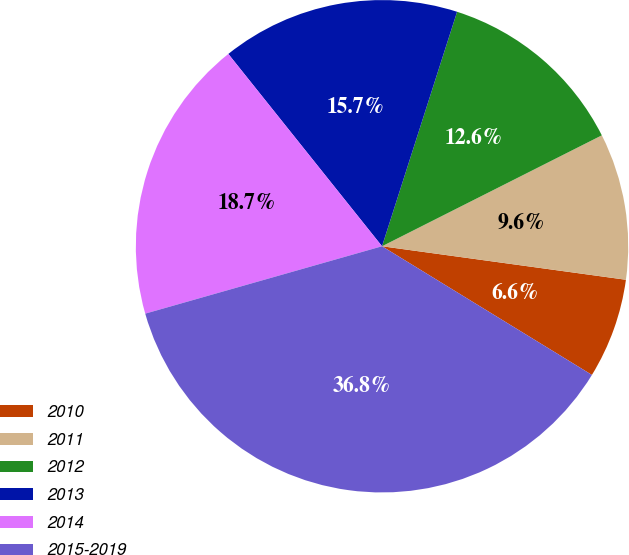Convert chart. <chart><loc_0><loc_0><loc_500><loc_500><pie_chart><fcel>2010<fcel>2011<fcel>2012<fcel>2013<fcel>2014<fcel>2015-2019<nl><fcel>6.58%<fcel>9.61%<fcel>12.63%<fcel>15.66%<fcel>18.68%<fcel>36.83%<nl></chart> 